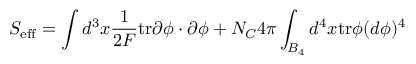Convert formula to latex. <formula><loc_0><loc_0><loc_500><loc_500>S _ { e f f } = \int d ^ { 3 } x \frac { 1 } { 2 F } t r \partial \phi \cdot \partial \phi + { N _ { C } } { 4 \pi } \int _ { B _ { 4 } } d ^ { 4 } x t r \phi ( d \phi ) ^ { 4 }</formula> 